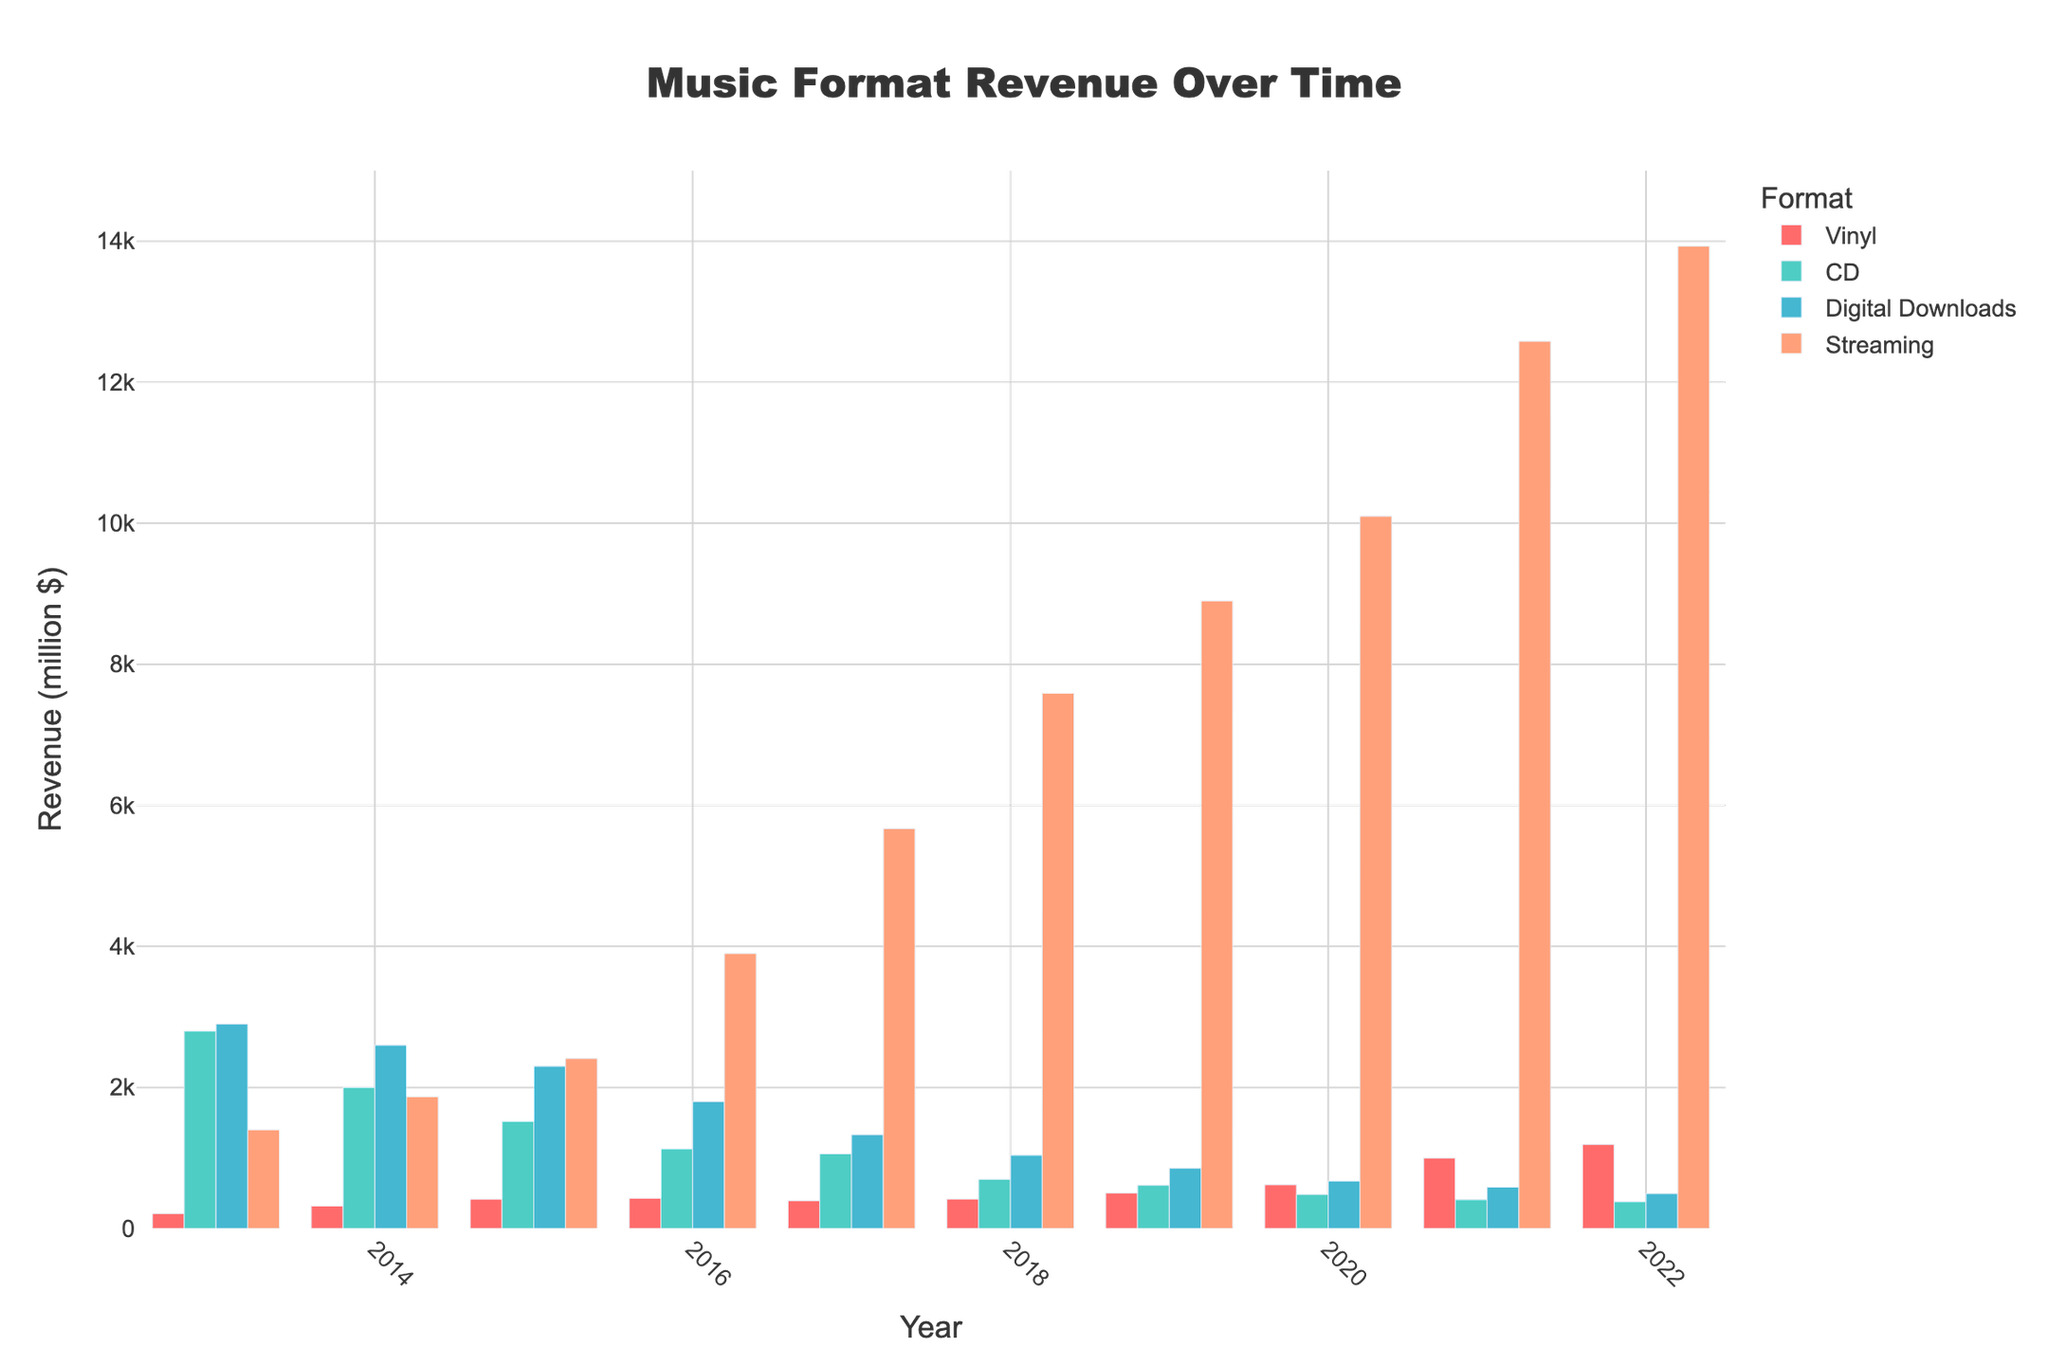What music format generated the most revenue in 2022? Looking at the heights of the bars corresponding to different formats in 2022, the streaming bar is the highest.
Answer: Streaming What's the total revenue generated by CDs across all years shown? Summing the revenue from CDs for each year: 2800+2000+1520+1130+1060+698+615+483+410+380. The total is 12096 million dollars.
Answer: 12096 million dollars How did the revenue from vinyl change from 2013 to 2022? Noticing the heights of the vinyl bars in 2013 and 2022, the vinyl revenue increased from 210 million dollars in 2013 to 1190 million dollars in 2022.
Answer: Increased Which year had the highest total revenue from all formats combined, and what was that total? Adding the revenues from all formats for each year and comparing: 2013 (2900+2800+210+1400 = 7310), 2014 (2600+2000+320+1870 = 6790), ..., 2022 (495+380+1190+13930 = 15995). The highest total was in 2022, with 15995 million dollars.
Answer: 2022, 15995 million dollars By how much did the revenue from digital downloads decrease from 2013 to 2022? The revenue for digital downloads in 2013 was 2900 million dollars and in 2022 was 495 million dollars. Subtracting these, 2900 - 495 = 2405 million dollars.
Answer: 2405 million dollars During which year did streaming revenue surpass digital downloads for the first time? Comparing the heights of the streaming and digital downloads bars across the years, streaming surpassed digital downloads in 2016.
Answer: 2016 What's the average revenue generated by streaming per year across the entire decade? Summing the streaming revenues for all the years and dividing by the number of years: (1400+1870+2410+3900+5670+7590+8900+10100+12580+13930)/10 = 72455/10 = 7245.5 million dollars.
Answer: 7245.5 million dollars Which format had the smallest revenue in 2015 and what was that amount? Observing the heights of the bars for 2015, vinyl generated the smallest revenue. The vinyl bar has the lowest height with 416 million dollars.
Answer: Vinyl, 416 million dollars How much more revenue did streaming generate in 2022 compared to 2013? The streaming revenue in 2022 was 13930 million dollars and in 2013 it was 1400 million dollars. Subtracting these, 13930 - 1400 = 12530 million dollars.
Answer: 12530 million dollars 